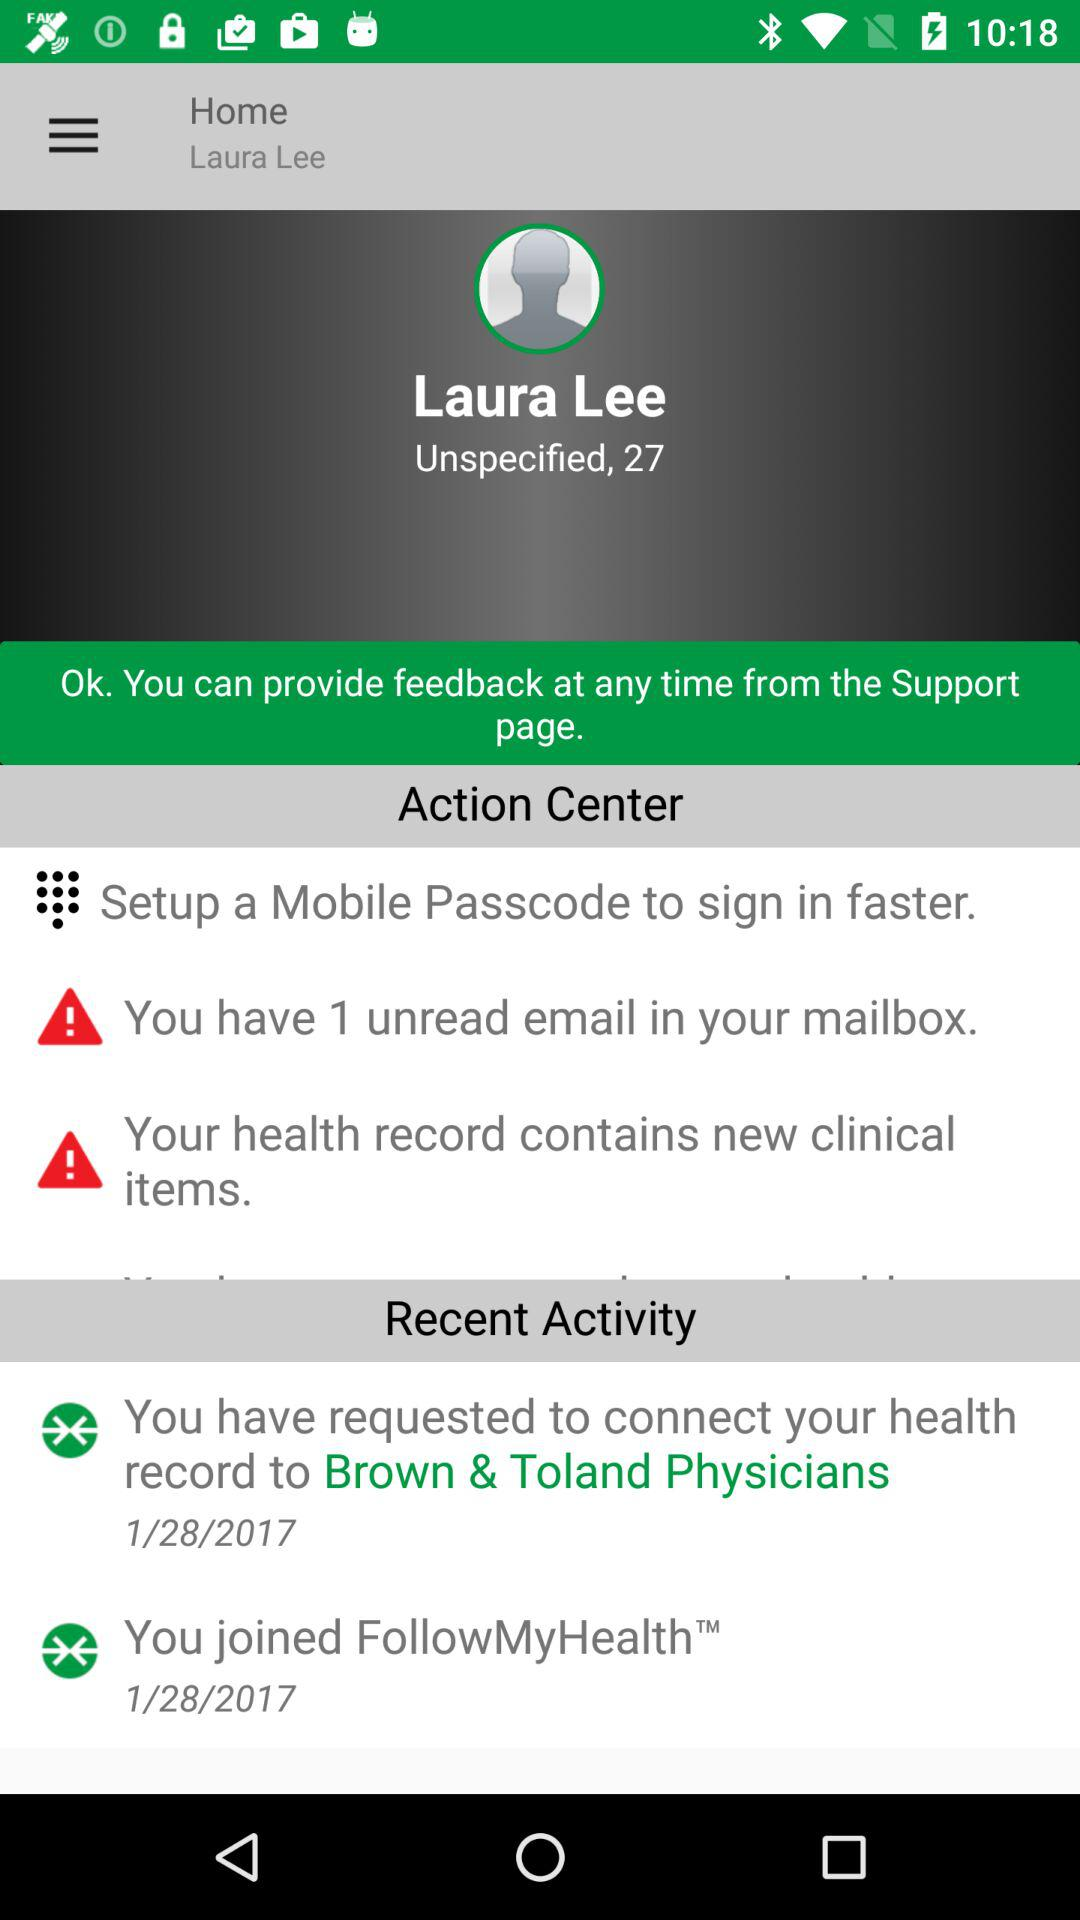On which date had I requested to connect my health record to Brown & Toland Physicians? You requested to connect your health record to Brown & Toland Physicians on January 28, 2017. 